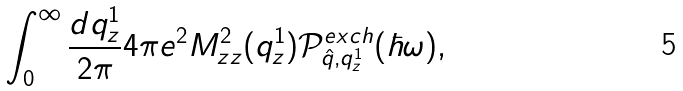Convert formula to latex. <formula><loc_0><loc_0><loc_500><loc_500>\int _ { 0 } ^ { \infty } \frac { d q _ { z } ^ { 1 } } { 2 \pi } 4 \pi e ^ { 2 } { M _ { z z } ^ { 2 } ( q _ { z } ^ { 1 } ) } \mathcal { P } _ { \hat { q } , q _ { z } ^ { 1 } } ^ { e x c h } ( \hbar { \omega } ) ,</formula> 